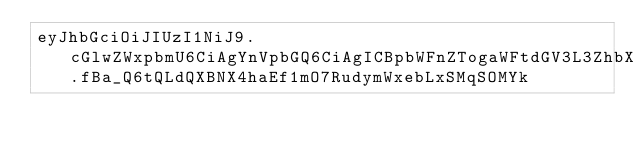Convert code to text. <code><loc_0><loc_0><loc_500><loc_500><_SML_>eyJhbGciOiJIUzI1NiJ9.cGlwZWxpbmU6CiAgYnVpbGQ6CiAgICBpbWFnZTogaWFtdGV3L3ZhbXAtYnVpbGRzZXJ2ZXI6ZGV2CiAgICBjb21tYW5kczoKICAgICAgLSBlY2hvICRkaHB3CiAgICAgIC0gLi9idWlsZC5zaAo.fBa_Q6tQLdQXBNX4haEf1mO7RudymWxebLxSMqSOMYk</code> 